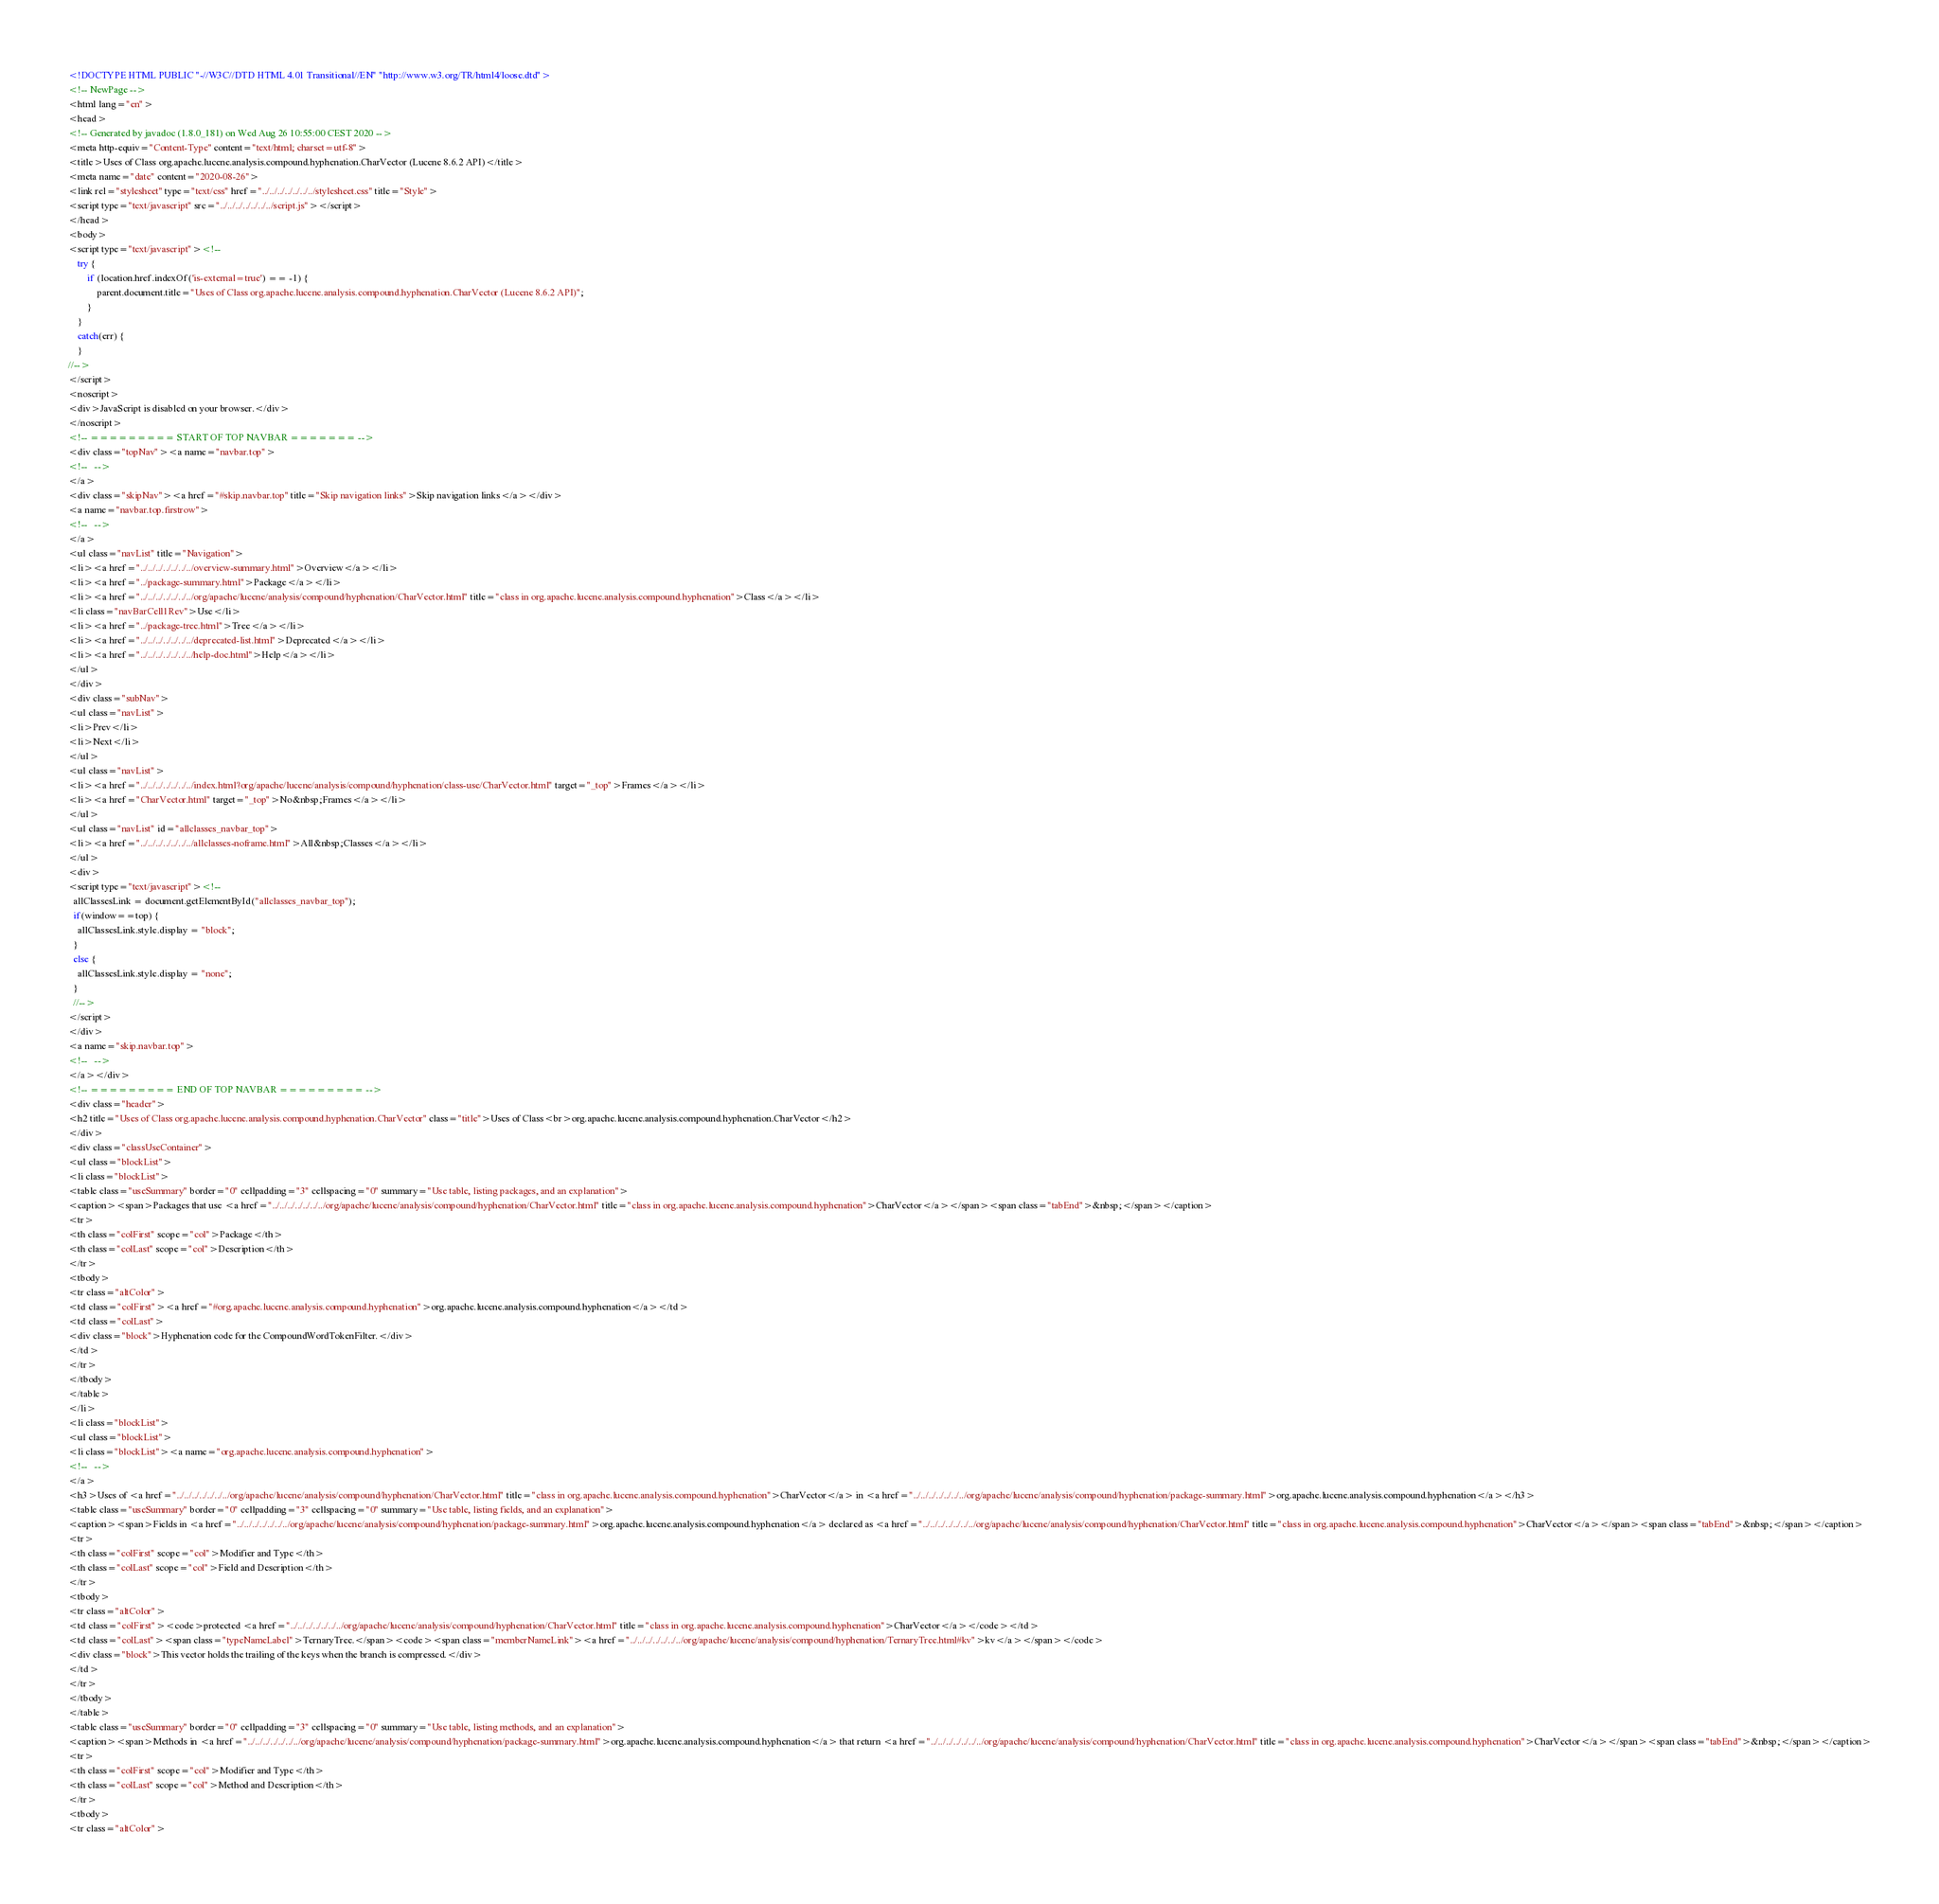Convert code to text. <code><loc_0><loc_0><loc_500><loc_500><_HTML_><!DOCTYPE HTML PUBLIC "-//W3C//DTD HTML 4.01 Transitional//EN" "http://www.w3.org/TR/html4/loose.dtd">
<!-- NewPage -->
<html lang="en">
<head>
<!-- Generated by javadoc (1.8.0_181) on Wed Aug 26 10:55:00 CEST 2020 -->
<meta http-equiv="Content-Type" content="text/html; charset=utf-8">
<title>Uses of Class org.apache.lucene.analysis.compound.hyphenation.CharVector (Lucene 8.6.2 API)</title>
<meta name="date" content="2020-08-26">
<link rel="stylesheet" type="text/css" href="../../../../../../../stylesheet.css" title="Style">
<script type="text/javascript" src="../../../../../../../script.js"></script>
</head>
<body>
<script type="text/javascript"><!--
    try {
        if (location.href.indexOf('is-external=true') == -1) {
            parent.document.title="Uses of Class org.apache.lucene.analysis.compound.hyphenation.CharVector (Lucene 8.6.2 API)";
        }
    }
    catch(err) {
    }
//-->
</script>
<noscript>
<div>JavaScript is disabled on your browser.</div>
</noscript>
<!-- ========= START OF TOP NAVBAR ======= -->
<div class="topNav"><a name="navbar.top">
<!--   -->
</a>
<div class="skipNav"><a href="#skip.navbar.top" title="Skip navigation links">Skip navigation links</a></div>
<a name="navbar.top.firstrow">
<!--   -->
</a>
<ul class="navList" title="Navigation">
<li><a href="../../../../../../../overview-summary.html">Overview</a></li>
<li><a href="../package-summary.html">Package</a></li>
<li><a href="../../../../../../../org/apache/lucene/analysis/compound/hyphenation/CharVector.html" title="class in org.apache.lucene.analysis.compound.hyphenation">Class</a></li>
<li class="navBarCell1Rev">Use</li>
<li><a href="../package-tree.html">Tree</a></li>
<li><a href="../../../../../../../deprecated-list.html">Deprecated</a></li>
<li><a href="../../../../../../../help-doc.html">Help</a></li>
</ul>
</div>
<div class="subNav">
<ul class="navList">
<li>Prev</li>
<li>Next</li>
</ul>
<ul class="navList">
<li><a href="../../../../../../../index.html?org/apache/lucene/analysis/compound/hyphenation/class-use/CharVector.html" target="_top">Frames</a></li>
<li><a href="CharVector.html" target="_top">No&nbsp;Frames</a></li>
</ul>
<ul class="navList" id="allclasses_navbar_top">
<li><a href="../../../../../../../allclasses-noframe.html">All&nbsp;Classes</a></li>
</ul>
<div>
<script type="text/javascript"><!--
  allClassesLink = document.getElementById("allclasses_navbar_top");
  if(window==top) {
    allClassesLink.style.display = "block";
  }
  else {
    allClassesLink.style.display = "none";
  }
  //-->
</script>
</div>
<a name="skip.navbar.top">
<!--   -->
</a></div>
<!-- ========= END OF TOP NAVBAR ========= -->
<div class="header">
<h2 title="Uses of Class org.apache.lucene.analysis.compound.hyphenation.CharVector" class="title">Uses of Class<br>org.apache.lucene.analysis.compound.hyphenation.CharVector</h2>
</div>
<div class="classUseContainer">
<ul class="blockList">
<li class="blockList">
<table class="useSummary" border="0" cellpadding="3" cellspacing="0" summary="Use table, listing packages, and an explanation">
<caption><span>Packages that use <a href="../../../../../../../org/apache/lucene/analysis/compound/hyphenation/CharVector.html" title="class in org.apache.lucene.analysis.compound.hyphenation">CharVector</a></span><span class="tabEnd">&nbsp;</span></caption>
<tr>
<th class="colFirst" scope="col">Package</th>
<th class="colLast" scope="col">Description</th>
</tr>
<tbody>
<tr class="altColor">
<td class="colFirst"><a href="#org.apache.lucene.analysis.compound.hyphenation">org.apache.lucene.analysis.compound.hyphenation</a></td>
<td class="colLast">
<div class="block">Hyphenation code for the CompoundWordTokenFilter.</div>
</td>
</tr>
</tbody>
</table>
</li>
<li class="blockList">
<ul class="blockList">
<li class="blockList"><a name="org.apache.lucene.analysis.compound.hyphenation">
<!--   -->
</a>
<h3>Uses of <a href="../../../../../../../org/apache/lucene/analysis/compound/hyphenation/CharVector.html" title="class in org.apache.lucene.analysis.compound.hyphenation">CharVector</a> in <a href="../../../../../../../org/apache/lucene/analysis/compound/hyphenation/package-summary.html">org.apache.lucene.analysis.compound.hyphenation</a></h3>
<table class="useSummary" border="0" cellpadding="3" cellspacing="0" summary="Use table, listing fields, and an explanation">
<caption><span>Fields in <a href="../../../../../../../org/apache/lucene/analysis/compound/hyphenation/package-summary.html">org.apache.lucene.analysis.compound.hyphenation</a> declared as <a href="../../../../../../../org/apache/lucene/analysis/compound/hyphenation/CharVector.html" title="class in org.apache.lucene.analysis.compound.hyphenation">CharVector</a></span><span class="tabEnd">&nbsp;</span></caption>
<tr>
<th class="colFirst" scope="col">Modifier and Type</th>
<th class="colLast" scope="col">Field and Description</th>
</tr>
<tbody>
<tr class="altColor">
<td class="colFirst"><code>protected <a href="../../../../../../../org/apache/lucene/analysis/compound/hyphenation/CharVector.html" title="class in org.apache.lucene.analysis.compound.hyphenation">CharVector</a></code></td>
<td class="colLast"><span class="typeNameLabel">TernaryTree.</span><code><span class="memberNameLink"><a href="../../../../../../../org/apache/lucene/analysis/compound/hyphenation/TernaryTree.html#kv">kv</a></span></code>
<div class="block">This vector holds the trailing of the keys when the branch is compressed.</div>
</td>
</tr>
</tbody>
</table>
<table class="useSummary" border="0" cellpadding="3" cellspacing="0" summary="Use table, listing methods, and an explanation">
<caption><span>Methods in <a href="../../../../../../../org/apache/lucene/analysis/compound/hyphenation/package-summary.html">org.apache.lucene.analysis.compound.hyphenation</a> that return <a href="../../../../../../../org/apache/lucene/analysis/compound/hyphenation/CharVector.html" title="class in org.apache.lucene.analysis.compound.hyphenation">CharVector</a></span><span class="tabEnd">&nbsp;</span></caption>
<tr>
<th class="colFirst" scope="col">Modifier and Type</th>
<th class="colLast" scope="col">Method and Description</th>
</tr>
<tbody>
<tr class="altColor"></code> 